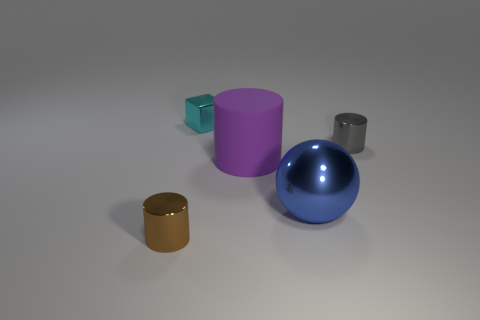Add 4 large brown cubes. How many objects exist? 9 Subtract all cylinders. How many objects are left? 2 Add 4 purple things. How many purple things are left? 5 Add 4 big purple matte balls. How many big purple matte balls exist? 4 Subtract 0 yellow blocks. How many objects are left? 5 Subtract all metal cubes. Subtract all small gray objects. How many objects are left? 3 